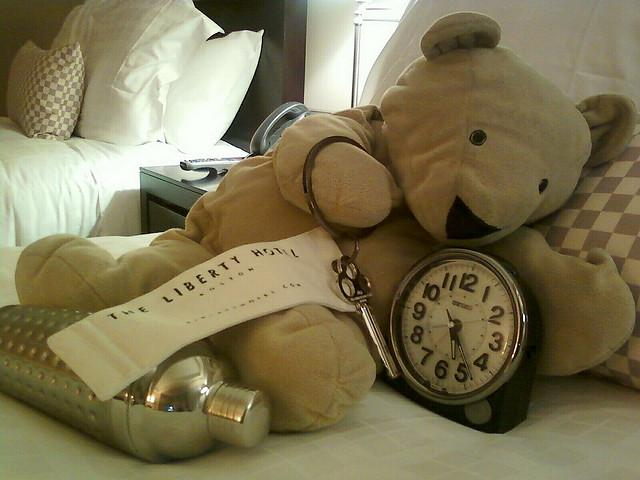What is hanging from the bear's wrist?

Choices:
A) key
B) watch
C) scissors
D) knife key 